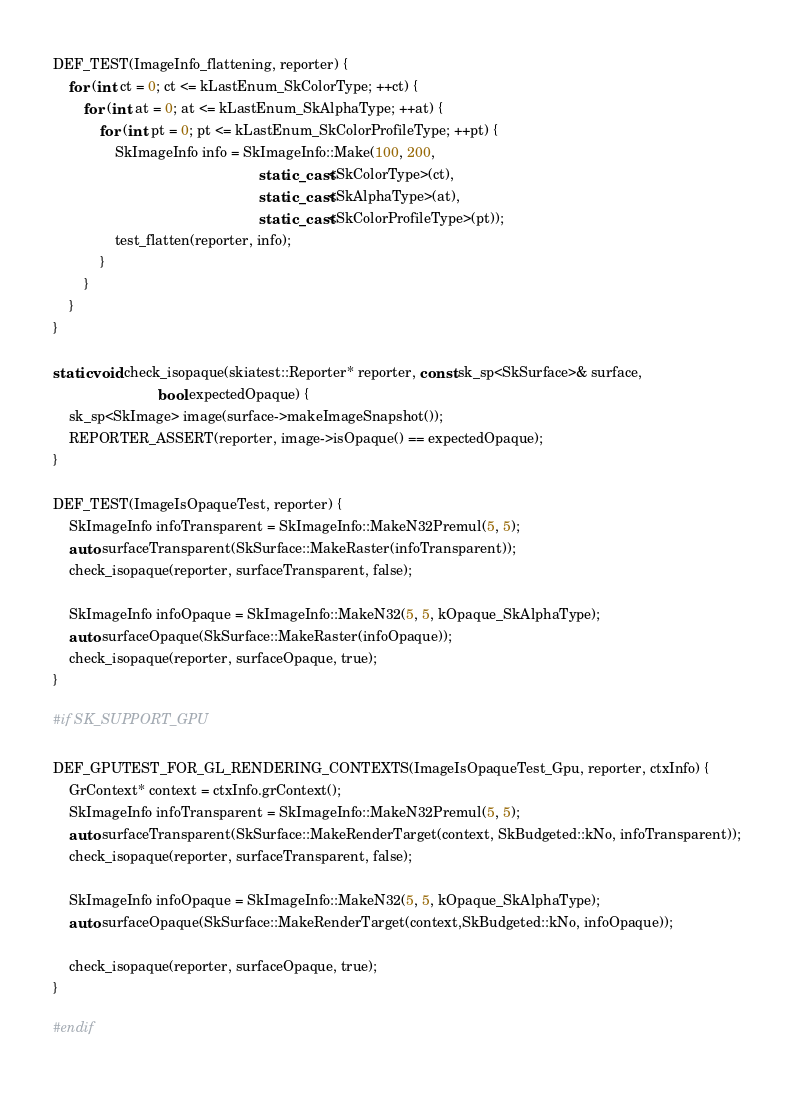<code> <loc_0><loc_0><loc_500><loc_500><_C++_>
DEF_TEST(ImageInfo_flattening, reporter) {
    for (int ct = 0; ct <= kLastEnum_SkColorType; ++ct) {
        for (int at = 0; at <= kLastEnum_SkAlphaType; ++at) {
            for (int pt = 0; pt <= kLastEnum_SkColorProfileType; ++pt) {
                SkImageInfo info = SkImageInfo::Make(100, 200,
                                                     static_cast<SkColorType>(ct),
                                                     static_cast<SkAlphaType>(at),
                                                     static_cast<SkColorProfileType>(pt));
                test_flatten(reporter, info);
            }
        }
    }
}

static void check_isopaque(skiatest::Reporter* reporter, const sk_sp<SkSurface>& surface,
                           bool expectedOpaque) {
    sk_sp<SkImage> image(surface->makeImageSnapshot());
    REPORTER_ASSERT(reporter, image->isOpaque() == expectedOpaque);
}

DEF_TEST(ImageIsOpaqueTest, reporter) {
    SkImageInfo infoTransparent = SkImageInfo::MakeN32Premul(5, 5);
    auto surfaceTransparent(SkSurface::MakeRaster(infoTransparent));
    check_isopaque(reporter, surfaceTransparent, false);

    SkImageInfo infoOpaque = SkImageInfo::MakeN32(5, 5, kOpaque_SkAlphaType);
    auto surfaceOpaque(SkSurface::MakeRaster(infoOpaque));
    check_isopaque(reporter, surfaceOpaque, true);
}

#if SK_SUPPORT_GPU

DEF_GPUTEST_FOR_GL_RENDERING_CONTEXTS(ImageIsOpaqueTest_Gpu, reporter, ctxInfo) {
    GrContext* context = ctxInfo.grContext();
    SkImageInfo infoTransparent = SkImageInfo::MakeN32Premul(5, 5);
    auto surfaceTransparent(SkSurface::MakeRenderTarget(context, SkBudgeted::kNo, infoTransparent));
    check_isopaque(reporter, surfaceTransparent, false);

    SkImageInfo infoOpaque = SkImageInfo::MakeN32(5, 5, kOpaque_SkAlphaType);
    auto surfaceOpaque(SkSurface::MakeRenderTarget(context,SkBudgeted::kNo, infoOpaque));

    check_isopaque(reporter, surfaceOpaque, true);
}

#endif
</code> 